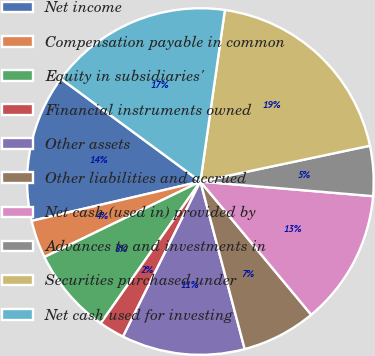Convert chart to OTSL. <chart><loc_0><loc_0><loc_500><loc_500><pie_chart><fcel>Net income<fcel>Compensation payable in common<fcel>Equity in subsidiaries'<fcel>Financial instruments owned<fcel>Other assets<fcel>Other liabilities and accrued<fcel>Net cash (used in) provided by<fcel>Advances to and investments in<fcel>Securities purchased under<fcel>Net cash used for investing<nl><fcel>13.75%<fcel>3.53%<fcel>8.07%<fcel>2.39%<fcel>11.48%<fcel>6.93%<fcel>12.61%<fcel>4.66%<fcel>19.43%<fcel>17.15%<nl></chart> 